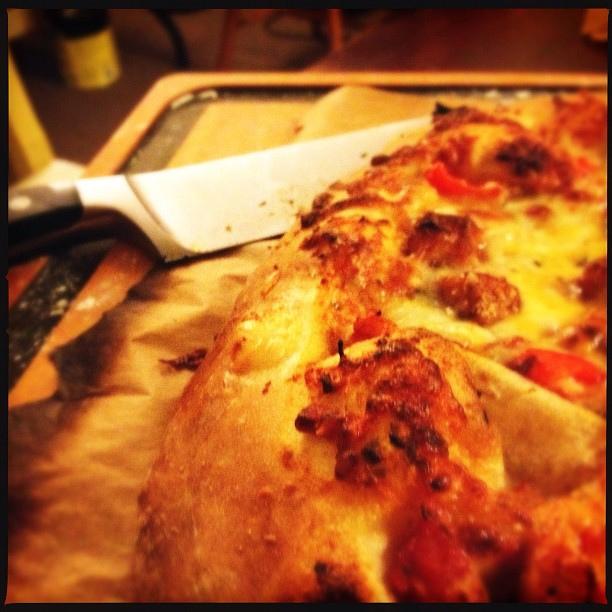What is this bread in?
Short answer required. Pizza. What food is this?
Give a very brief answer. Pizza. What color is the knife handle?
Concise answer only. Black. What is being cooked?
Be succinct. Pizza. Is the pizza on a baking tray?
Be succinct. Yes. 